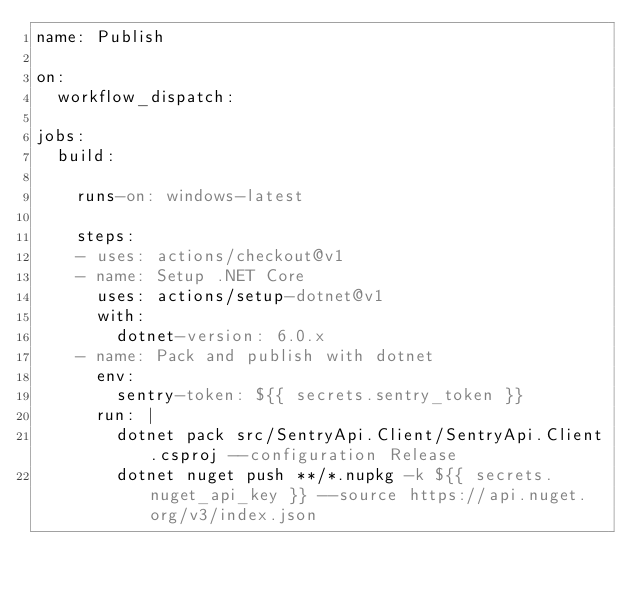Convert code to text. <code><loc_0><loc_0><loc_500><loc_500><_YAML_>name: Publish

on: 
  workflow_dispatch:

jobs:
  build:

    runs-on: windows-latest
    
    steps:
    - uses: actions/checkout@v1
    - name: Setup .NET Core
      uses: actions/setup-dotnet@v1
      with:
        dotnet-version: 6.0.x
    - name: Pack and publish with dotnet
      env:
        sentry-token: ${{ secrets.sentry_token }}
      run: |
        dotnet pack src/SentryApi.Client/SentryApi.Client.csproj --configuration Release
        dotnet nuget push **/*.nupkg -k ${{ secrets.nuget_api_key }} --source https://api.nuget.org/v3/index.json
</code> 